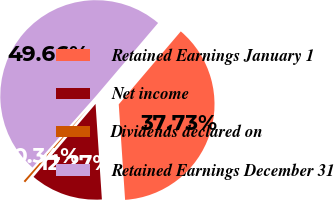Convert chart. <chart><loc_0><loc_0><loc_500><loc_500><pie_chart><fcel>Retained Earnings January 1<fcel>Net income<fcel>Dividends declared on<fcel>Retained Earnings December 31<nl><fcel>37.73%<fcel>12.27%<fcel>0.34%<fcel>49.66%<nl></chart> 